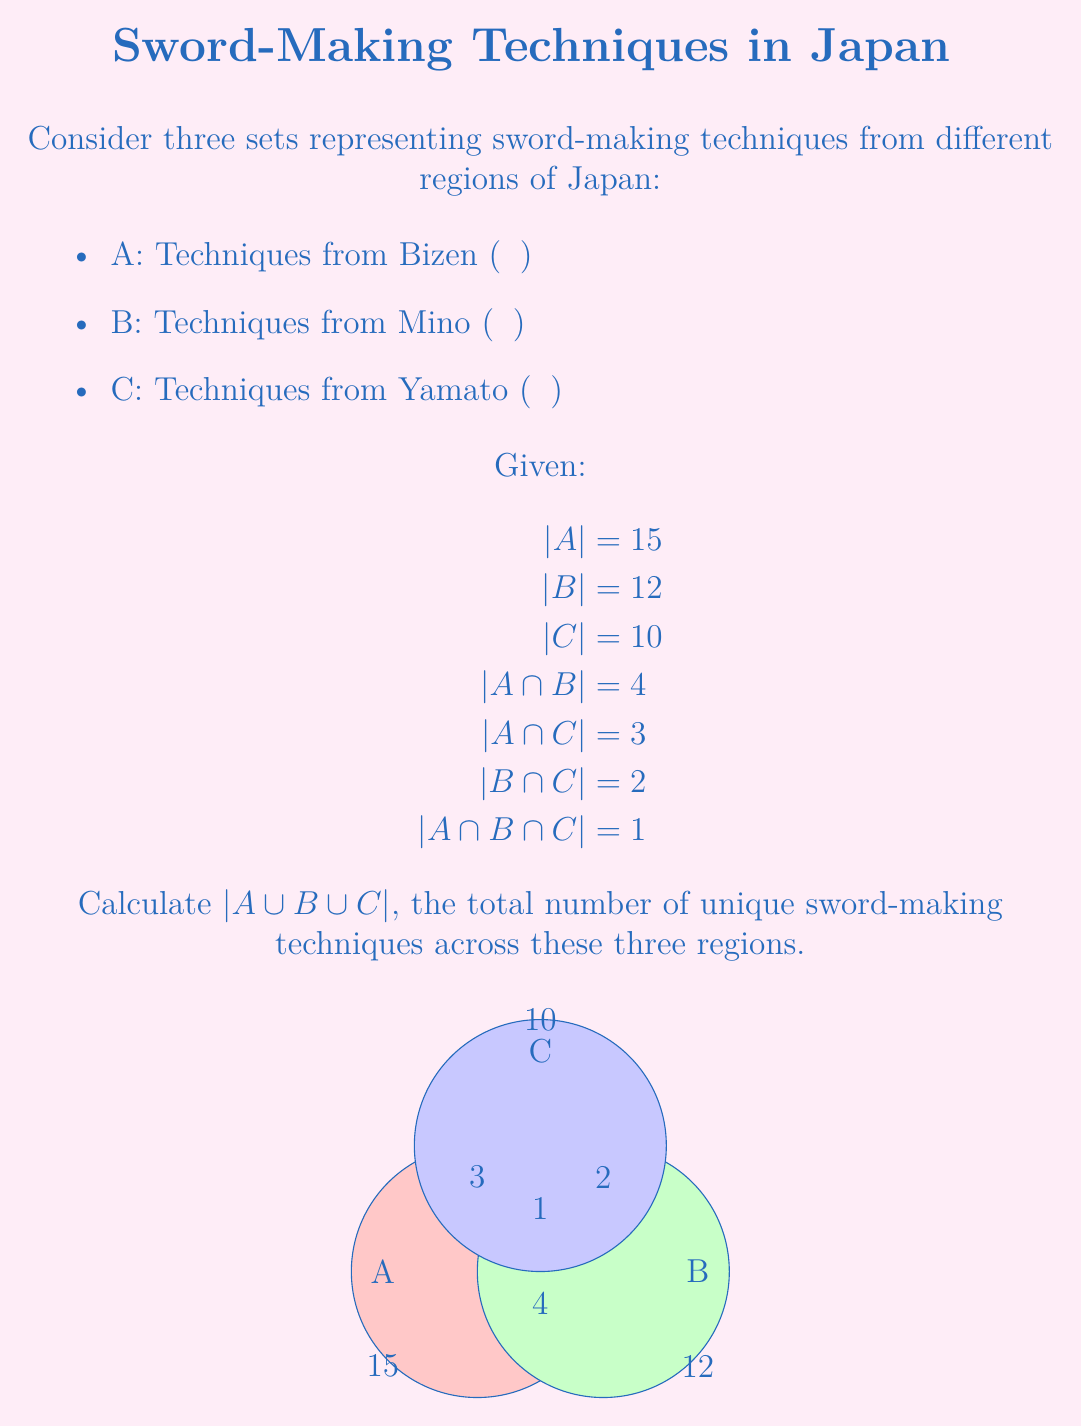Solve this math problem. To solve this problem, we'll use the Inclusion-Exclusion Principle for three sets:

$|A \cup B \cup C| = |A| + |B| + |C| - |A \cap B| - |A \cap C| - |B \cap C| + |A \cap B \cap C|$

Let's substitute the given values:

$|A \cup B \cup C| = 15 + 12 + 10 - 4 - 3 - 2 + 1$

Now, let's calculate step by step:

1) First, add the individual set sizes:
   $15 + 12 + 10 = 37$

2) Then, subtract the pairwise intersections:
   $37 - 4 - 3 - 2 = 28$

3) Finally, add back the triple intersection:
   $28 + 1 = 29$

Therefore, $|A \cup B \cup C| = 29$

This means there are 29 unique sword-making techniques across the three regions of Bizen, Mino, and Yamato.
Answer: 29 